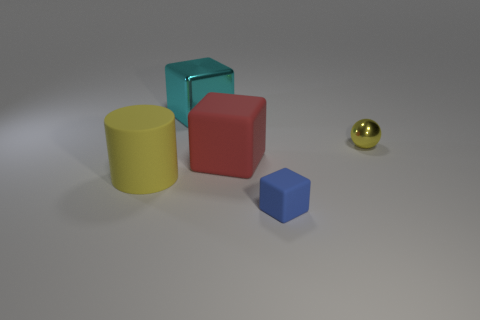The ball is what size?
Offer a very short reply. Small. Is there anything else that is the same shape as the small yellow metallic thing?
Your answer should be compact. No. What is the size of the metal thing right of the large cyan object?
Your answer should be very brief. Small. There is a cyan block that is behind the blue thing; what number of large matte cylinders are on the right side of it?
Your answer should be compact. 0. Does the yellow object right of the large shiny thing have the same shape as the large matte thing in front of the red matte cube?
Keep it short and to the point. No. How many large objects are both on the right side of the cyan block and in front of the big red block?
Make the answer very short. 0. Are there any tiny rubber cubes that have the same color as the small ball?
Your answer should be very brief. No. There is a rubber object that is the same size as the metallic sphere; what shape is it?
Provide a short and direct response. Cube. Are there any objects in front of the large cyan shiny thing?
Ensure brevity in your answer.  Yes. Are the small object that is in front of the yellow sphere and the small thing that is behind the big yellow rubber cylinder made of the same material?
Give a very brief answer. No. 